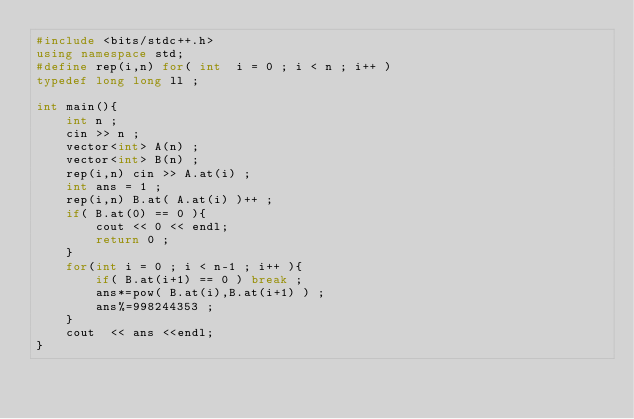Convert code to text. <code><loc_0><loc_0><loc_500><loc_500><_C++_>#include <bits/stdc++.h>
using namespace std;
#define rep(i,n) for( int  i = 0 ; i < n ; i++ ) 
typedef long long ll ;

int main(){
    int n ;
    cin >> n ;
    vector<int> A(n) ;
    vector<int> B(n) ;
    rep(i,n) cin >> A.at(i) ;
    int ans = 1 ;
    rep(i,n) B.at( A.at(i) )++ ;
    if( B.at(0) == 0 ){
        cout << 0 << endl;
        return 0 ;
    }
    for(int i = 0 ; i < n-1 ; i++ ){
        if( B.at(i+1) == 0 ) break ;
        ans*=pow( B.at(i),B.at(i+1) ) ;
        ans%=998244353 ;
    }
    cout  << ans <<endl;
}
</code> 